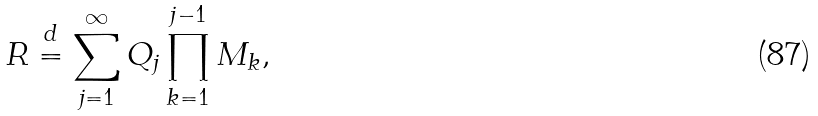<formula> <loc_0><loc_0><loc_500><loc_500>R \stackrel { d } { = } \sum _ { j = 1 } ^ { \infty } Q _ { j } \prod _ { k = 1 } ^ { j - 1 } M _ { k } ,</formula> 